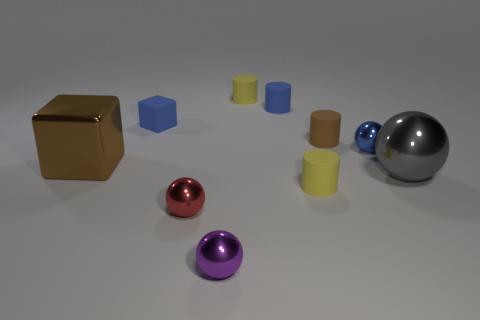Subtract 1 spheres. How many spheres are left? 3 Subtract all blocks. How many objects are left? 8 Subtract 0 cyan cubes. How many objects are left? 10 Subtract all small cylinders. Subtract all brown cylinders. How many objects are left? 5 Add 2 matte things. How many matte things are left? 7 Add 8 gray metallic balls. How many gray metallic balls exist? 9 